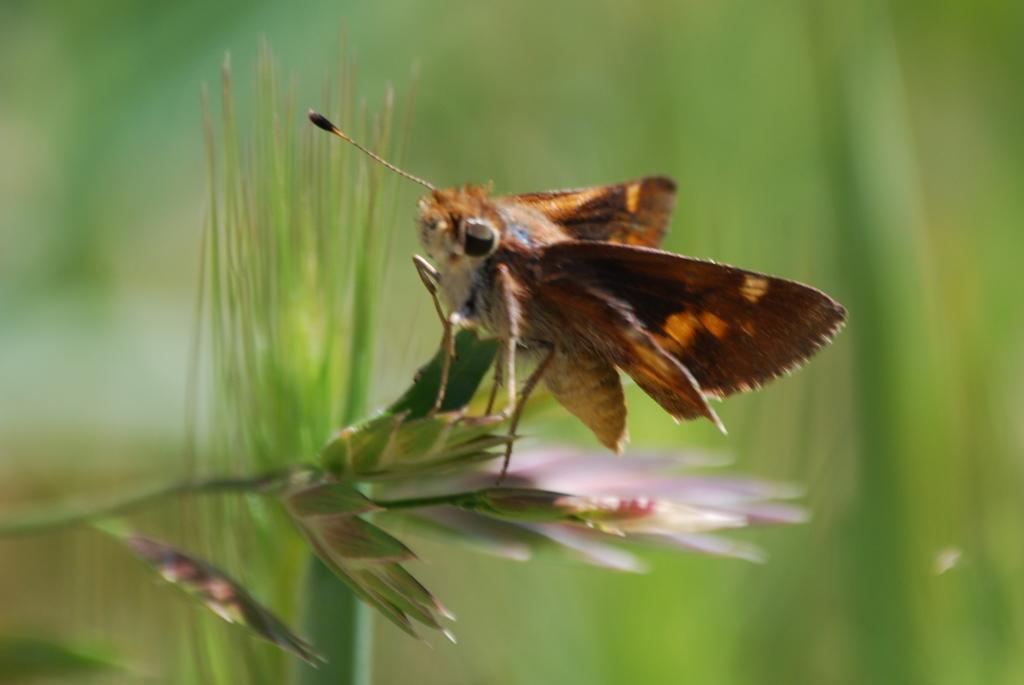What is present in the image? There is a fly in the image. Where is the fly located? The fly is on a plant. What error did the fly make in the image? There is no indication of an error made by the fly in the image. How does the fly's stomach appear in the image? The image does not show the fly's stomach, so it cannot be described. 